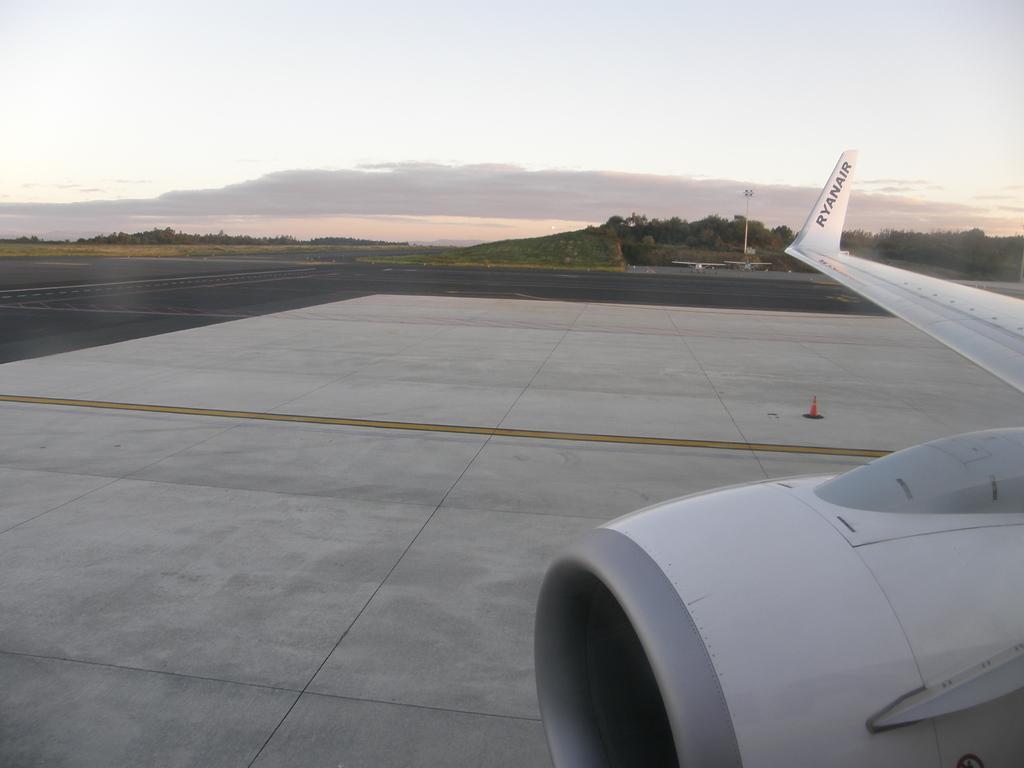How would you summarize this image in a sentence or two? This image is taken outdoors. At the top of the image there is the sky with clouds. In the background there are many trees and plants on the ground. There is a pole. At the bottom of the image there is a runway. On the right side of the image there is an airplane on the runway. 